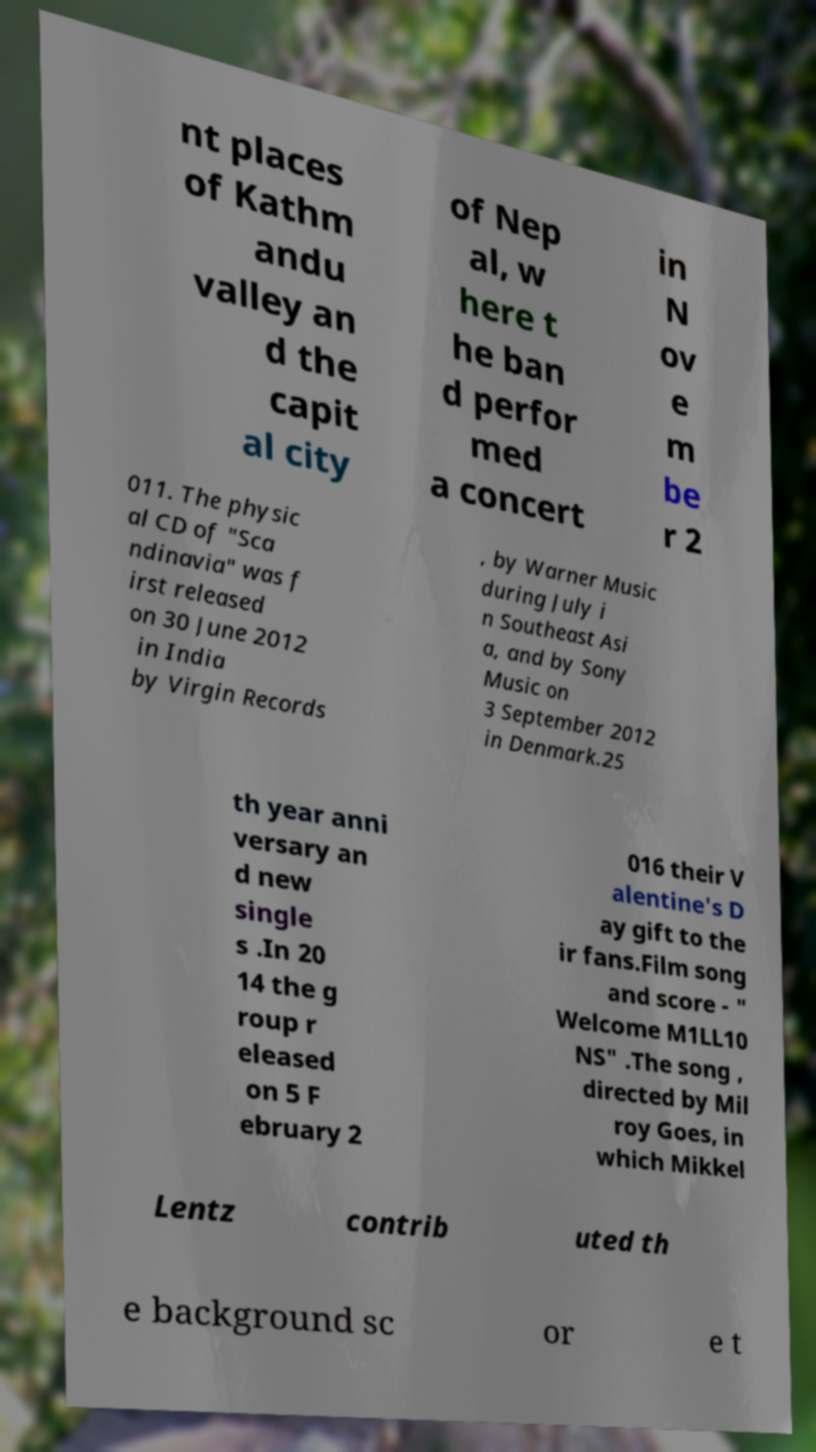Please identify and transcribe the text found in this image. nt places of Kathm andu valley an d the capit al city of Nep al, w here t he ban d perfor med a concert in N ov e m be r 2 011. The physic al CD of "Sca ndinavia" was f irst released on 30 June 2012 in India by Virgin Records , by Warner Music during July i n Southeast Asi a, and by Sony Music on 3 September 2012 in Denmark.25 th year anni versary an d new single s .In 20 14 the g roup r eleased on 5 F ebruary 2 016 their V alentine's D ay gift to the ir fans.Film song and score - " Welcome M1LL10 NS" .The song , directed by Mil roy Goes, in which Mikkel Lentz contrib uted th e background sc or e t 